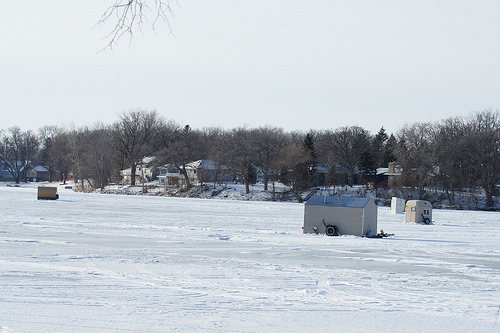<image>
Is there a house on the water? Yes. Looking at the image, I can see the house is positioned on top of the water, with the water providing support. 